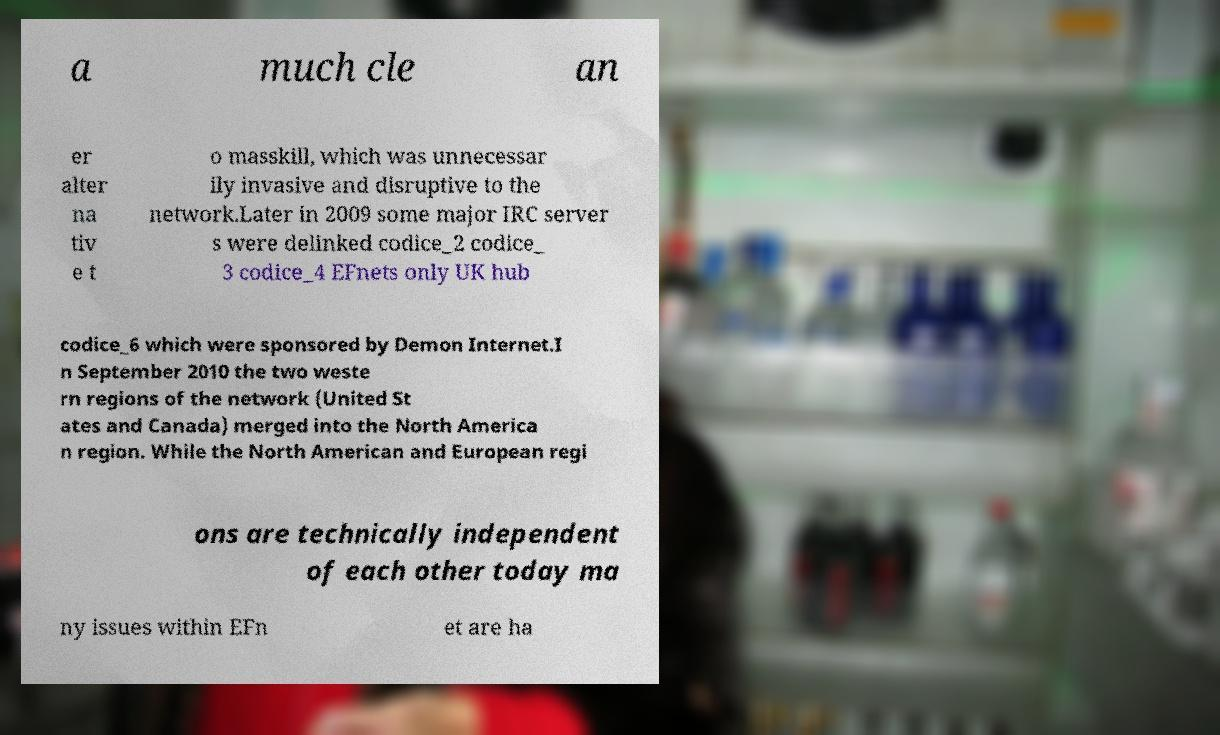Can you accurately transcribe the text from the provided image for me? a much cle an er alter na tiv e t o masskill, which was unnecessar ily invasive and disruptive to the network.Later in 2009 some major IRC server s were delinked codice_2 codice_ 3 codice_4 EFnets only UK hub codice_6 which were sponsored by Demon Internet.I n September 2010 the two weste rn regions of the network (United St ates and Canada) merged into the North America n region. While the North American and European regi ons are technically independent of each other today ma ny issues within EFn et are ha 